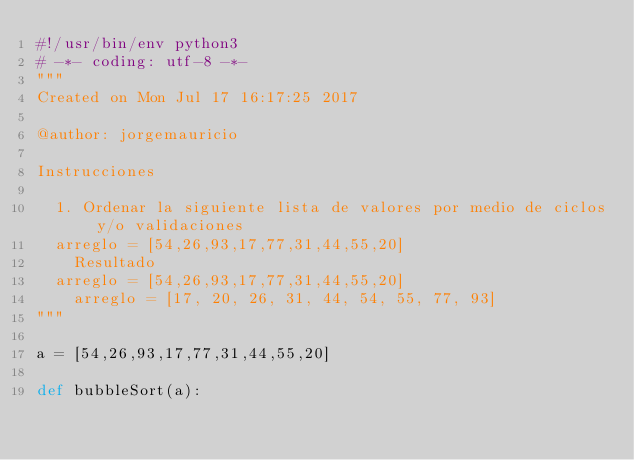Convert code to text. <code><loc_0><loc_0><loc_500><loc_500><_Python_>#!/usr/bin/env python3
# -*- coding: utf-8 -*-
"""
Created on Mon Jul 17 16:17:25 2017

@author: jorgemauricio

Instrucciones

	1. Ordenar la siguiente lista de valores por medio de ciclos y/o validaciones
	arreglo = [54,26,93,17,77,31,44,55,20]
    Resultado
	arreglo = [54,26,93,17,77,31,44,55,20]
    arreglo = [17, 20, 26, 31, 44, 54, 55, 77, 93]
"""

a = [54,26,93,17,77,31,44,55,20]

def bubbleSort(a):</code> 